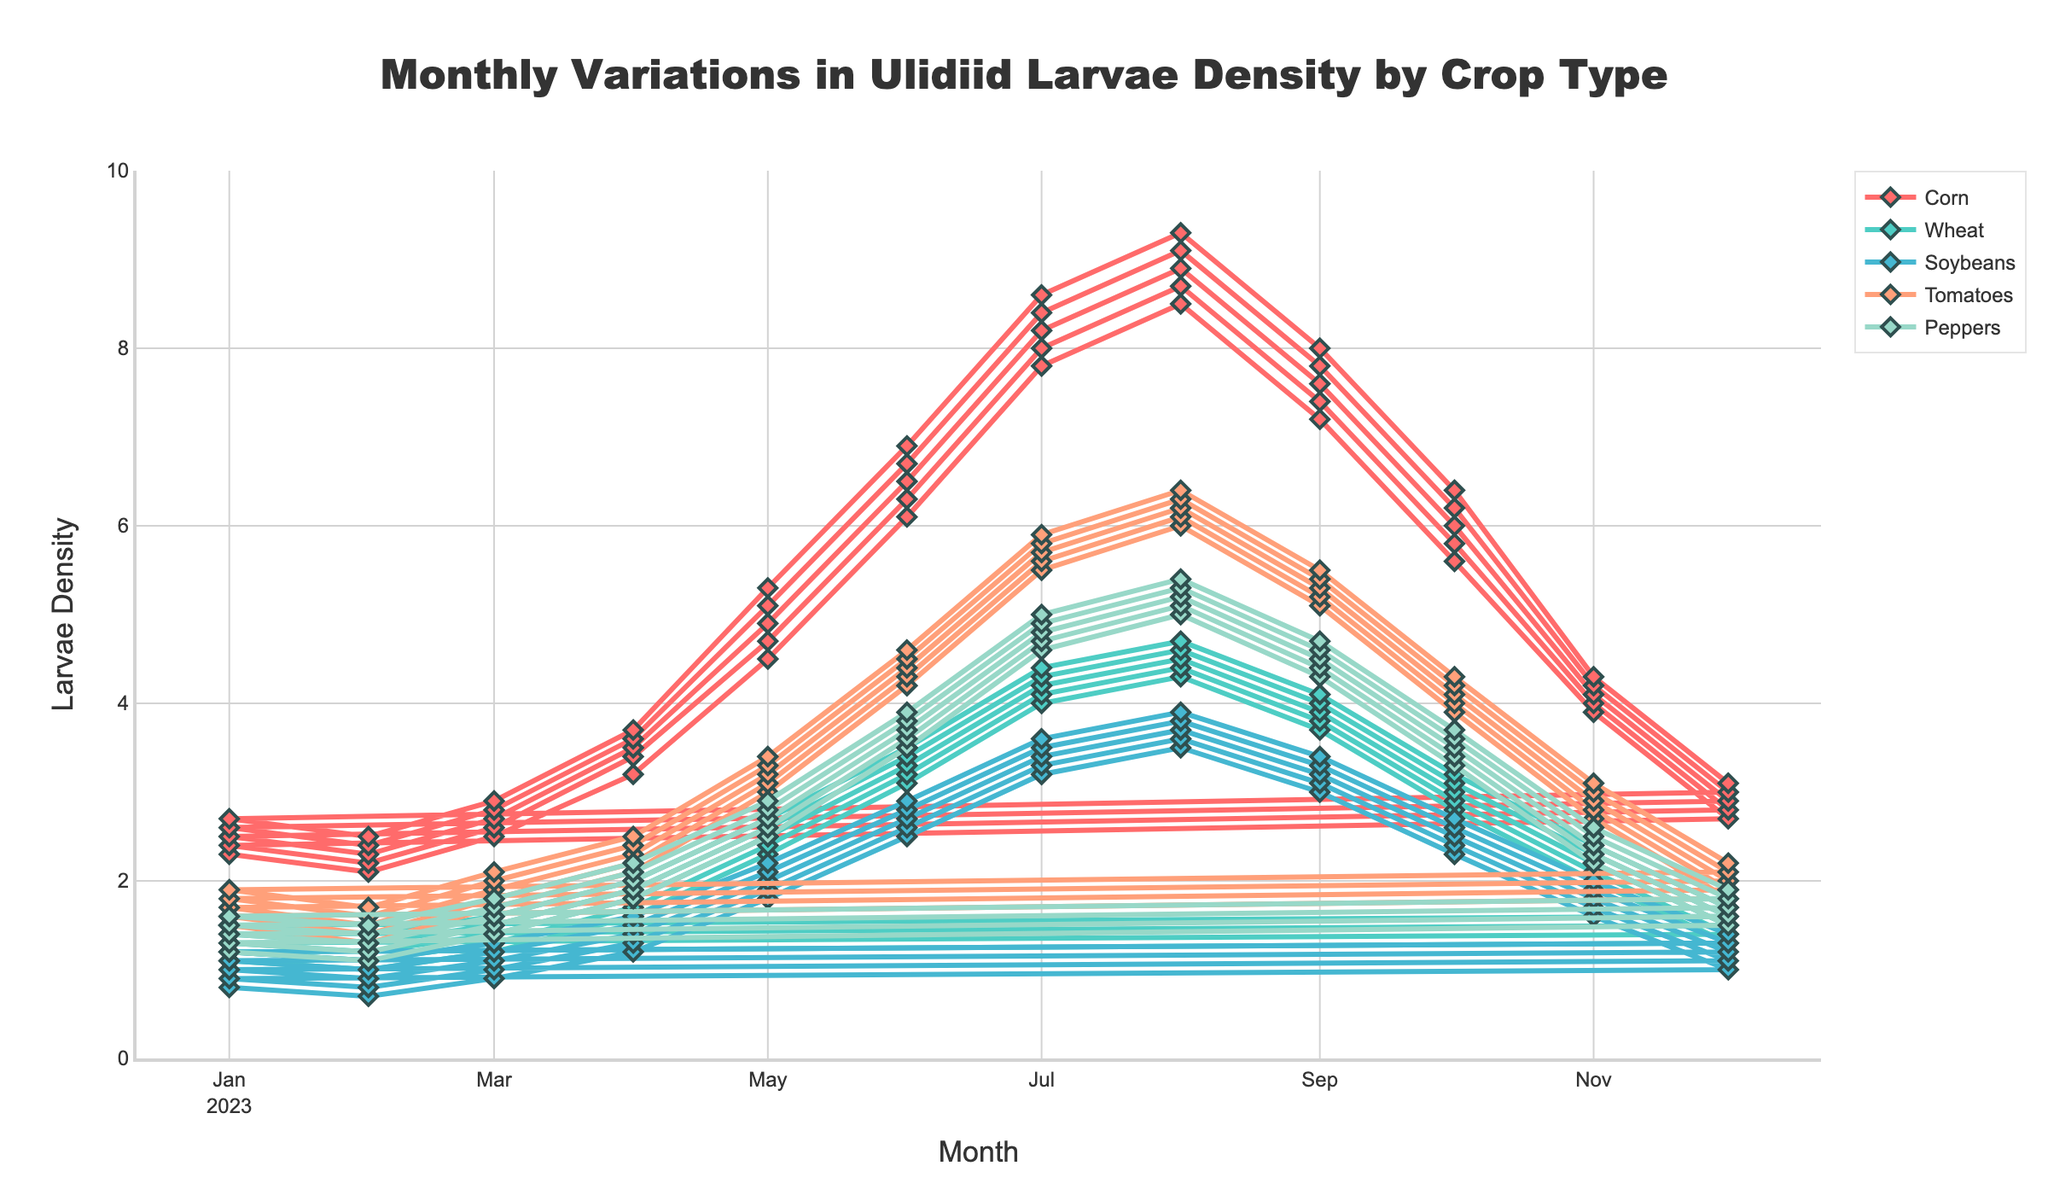Which crop has the highest peak larvae density? The peak larvae density can be determined by looking at the highest point on the lines for each crop. The crop that reaches the highest value on the y-axis is the one with the highest peak density. By observing the plot, the line for Corn reaches the highest peak value around August.
Answer: Corn In which month does Wheat have its highest larvae density? Locate the line for Wheat, which is colored differently from the other crops, and identify the point where it reaches the maximum y-value. This peak occurs in August.
Answer: August What is the difference in larvae density between Corn and Soybeans in July? Identify the y-values for Corn and Soybeans in July from the graph. Subtract the Soybeans y-value from the Corn y-value to find the difference. Corn has a y-value of 8.6, and Soybeans has a y-value of 3.6 in July, so the difference is 8.6 - 3.6.
Answer: 5.0 How does the larvae density for Tomatoes change from January to December? Follow the line corresponding to Tomatoes from January to December. Note the general trend over the months, whether it increases, decreases, or varies. The larvae density for Tomatoes starts at around 1.5 in January and rises to about 2.2 in December, with a peak in the middle of the year around August.
Answer: Increases overall with a peak in August Which months show a decrease in larvae density for Peppers compared to the previous month? Follow the line for Peppers and observe the trend from one month to the next. Months with a negative gradient indicate a decrease. Decreases can be seen for Peppers in September, October, November, and December.
Answer: September, October, November, December How does the larvae density of Corn compare to Wheat from May to August? Observe the trends for both Corn and Wheat between May and August. Notice the y-values for each crop in these months and visually compare them. Corn consistently has a higher larvae density than Wheat during May to August.
Answer: Corn is higher What is the average larvae density for Soybeans over the full period? Sum the y-values for Soybeans across all months and divide by the number of months to get the average. Total sum is 110.7, and there are 60 data points (12 months × 5 years), so the average is 110.7 / 60.
Answer: 1.845 Does the larvae density for Peppers ever surpass that of Tomatoes? Compare the y-values for Peppers and Tomatoes across all months by observing the lines close to each other. Peppers sometimes have higher y-values than Tomatoes, notably between July and September.
Answer: Yes 